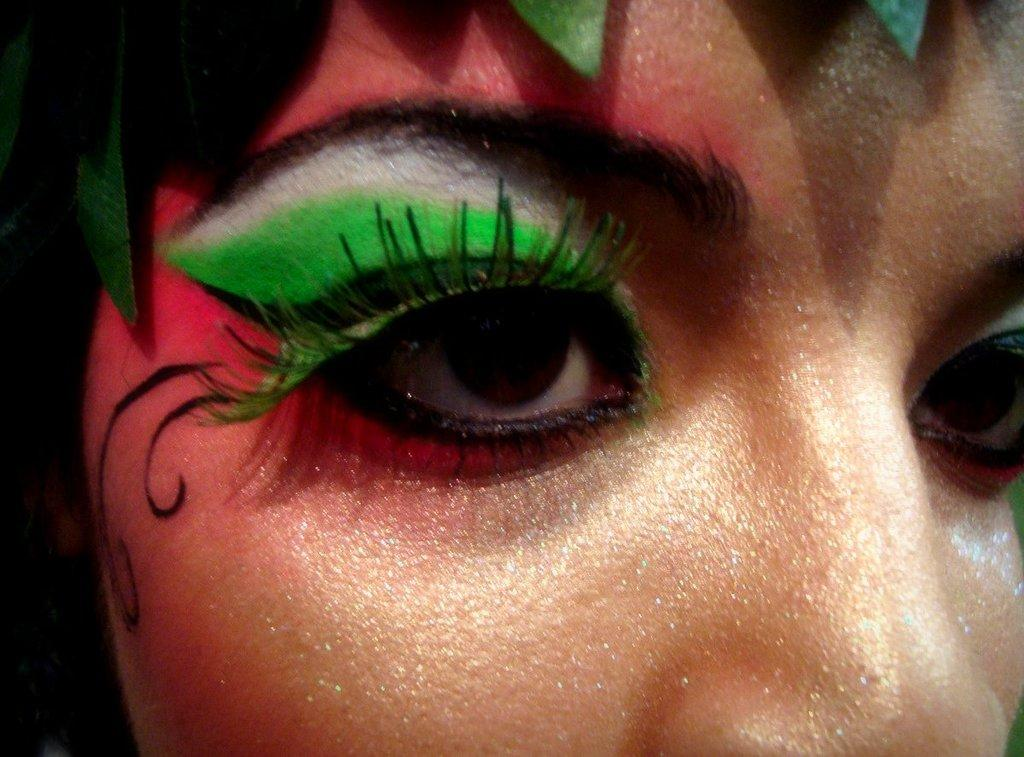What is the main subject of the image? The main subject of the image is a woman's eye. Can you describe any specific details about the eye? There is a green color on her skin. Can you see an owl perched on a twig in the image? No, there is no owl or twig present in the image; it is a close-up of a woman's eye. 